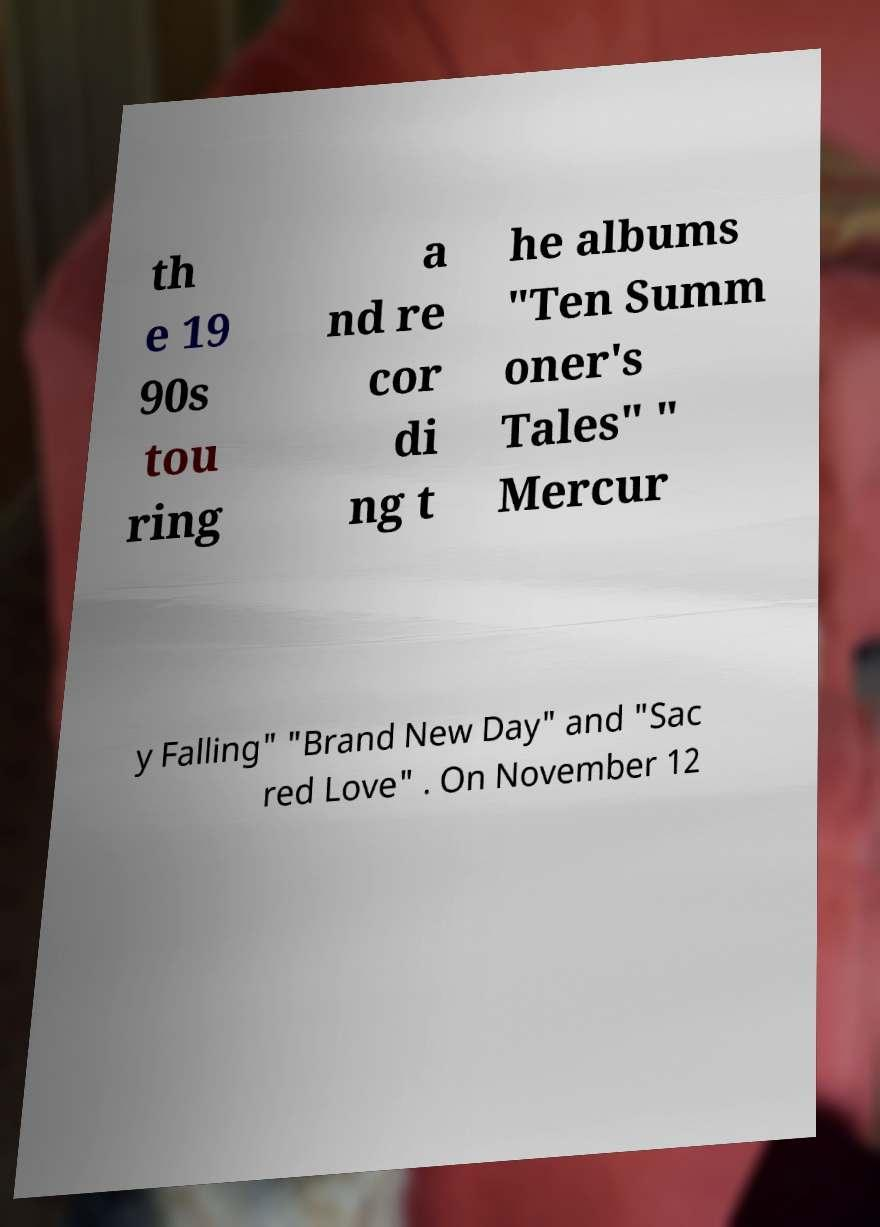What messages or text are displayed in this image? I need them in a readable, typed format. th e 19 90s tou ring a nd re cor di ng t he albums "Ten Summ oner's Tales" " Mercur y Falling" "Brand New Day" and "Sac red Love" . On November 12 